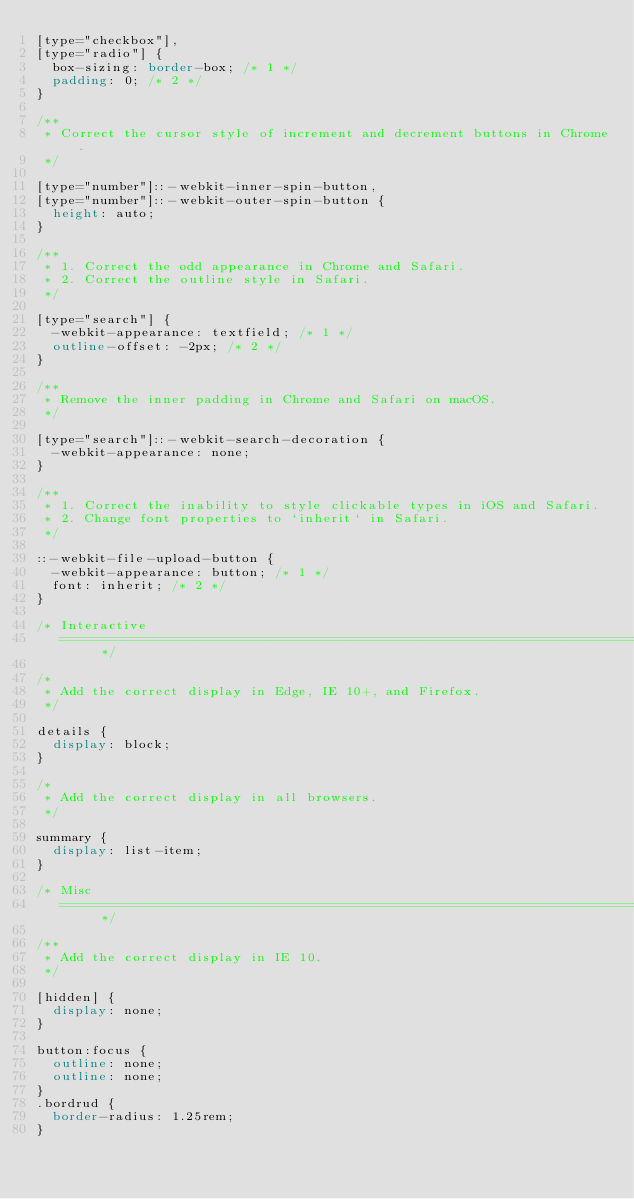Convert code to text. <code><loc_0><loc_0><loc_500><loc_500><_CSS_>[type="checkbox"],
[type="radio"] {
  box-sizing: border-box; /* 1 */
  padding: 0; /* 2 */
}

/**
 * Correct the cursor style of increment and decrement buttons in Chrome.
 */

[type="number"]::-webkit-inner-spin-button,
[type="number"]::-webkit-outer-spin-button {
  height: auto;
}

/**
 * 1. Correct the odd appearance in Chrome and Safari.
 * 2. Correct the outline style in Safari.
 */

[type="search"] {
  -webkit-appearance: textfield; /* 1 */
  outline-offset: -2px; /* 2 */
}

/**
 * Remove the inner padding in Chrome and Safari on macOS.
 */

[type="search"]::-webkit-search-decoration {
  -webkit-appearance: none;
}

/**
 * 1. Correct the inability to style clickable types in iOS and Safari.
 * 2. Change font properties to `inherit` in Safari.
 */

::-webkit-file-upload-button {
  -webkit-appearance: button; /* 1 */
  font: inherit; /* 2 */
}

/* Interactive
   ========================================================================== */

/*
 * Add the correct display in Edge, IE 10+, and Firefox.
 */

details {
  display: block;
}

/*
 * Add the correct display in all browsers.
 */

summary {
  display: list-item;
}

/* Misc
   ========================================================================== */

/**
 * Add the correct display in IE 10.
 */

[hidden] {
  display: none;
}

button:focus {
  outline: none;
  outline: none;
}
.bordrud {
  border-radius: 1.25rem;
}
</code> 